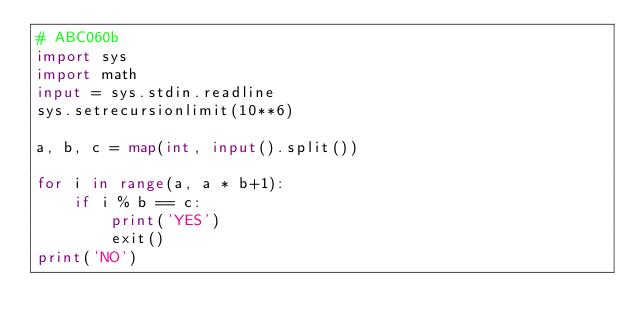<code> <loc_0><loc_0><loc_500><loc_500><_Python_># ABC060b
import sys
import math
input = sys.stdin.readline
sys.setrecursionlimit(10**6)

a, b, c = map(int, input().split())

for i in range(a, a * b+1):
    if i % b == c:
        print('YES')
        exit()
print('NO')</code> 